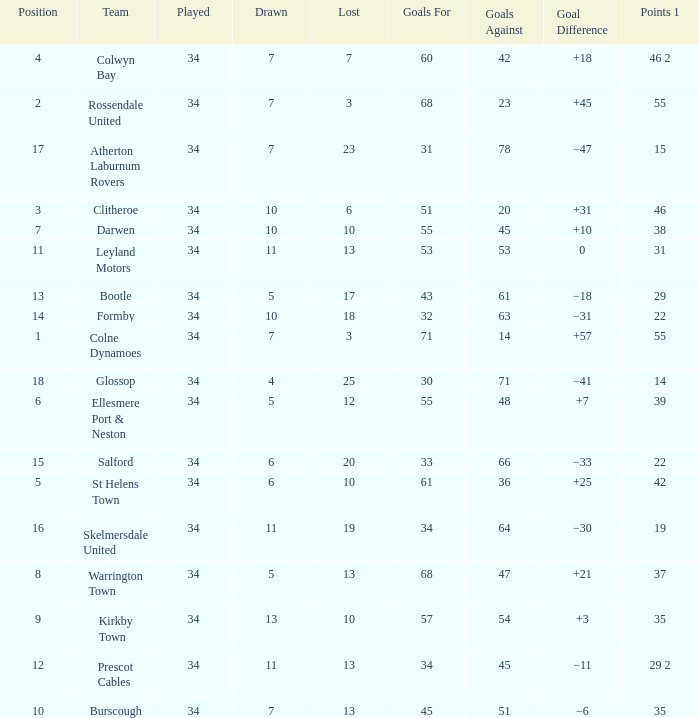Can you give me this table as a dict? {'header': ['Position', 'Team', 'Played', 'Drawn', 'Lost', 'Goals For', 'Goals Against', 'Goal Difference', 'Points 1'], 'rows': [['4', 'Colwyn Bay', '34', '7', '7', '60', '42', '+18', '46 2'], ['2', 'Rossendale United', '34', '7', '3', '68', '23', '+45', '55'], ['17', 'Atherton Laburnum Rovers', '34', '7', '23', '31', '78', '−47', '15'], ['3', 'Clitheroe', '34', '10', '6', '51', '20', '+31', '46'], ['7', 'Darwen', '34', '10', '10', '55', '45', '+10', '38'], ['11', 'Leyland Motors', '34', '11', '13', '53', '53', '0', '31'], ['13', 'Bootle', '34', '5', '17', '43', '61', '−18', '29'], ['14', 'Formby', '34', '10', '18', '32', '63', '−31', '22'], ['1', 'Colne Dynamoes', '34', '7', '3', '71', '14', '+57', '55'], ['18', 'Glossop', '34', '4', '25', '30', '71', '−41', '14'], ['6', 'Ellesmere Port & Neston', '34', '5', '12', '55', '48', '+7', '39'], ['15', 'Salford', '34', '6', '20', '33', '66', '−33', '22'], ['5', 'St Helens Town', '34', '6', '10', '61', '36', '+25', '42'], ['16', 'Skelmersdale United', '34', '11', '19', '34', '64', '−30', '19'], ['8', 'Warrington Town', '34', '5', '13', '68', '47', '+21', '37'], ['9', 'Kirkby Town', '34', '13', '10', '57', '54', '+3', '35'], ['12', 'Prescot Cables', '34', '11', '13', '34', '45', '−11', '29 2'], ['10', 'Burscough', '34', '7', '13', '45', '51', '−6', '35']]} Which Goals For has a Played larger than 34? None. 